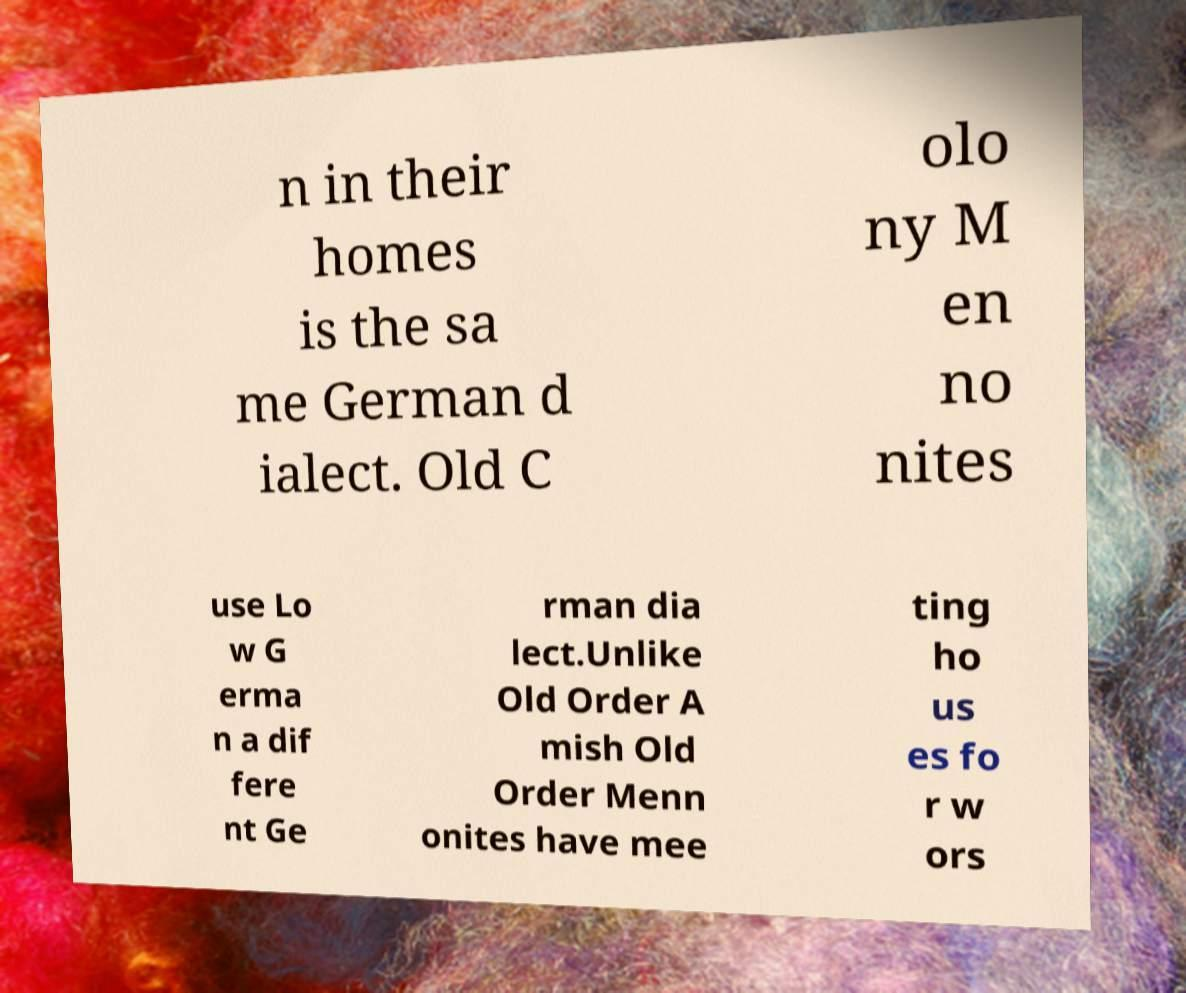For documentation purposes, I need the text within this image transcribed. Could you provide that? n in their homes is the sa me German d ialect. Old C olo ny M en no nites use Lo w G erma n a dif fere nt Ge rman dia lect.Unlike Old Order A mish Old Order Menn onites have mee ting ho us es fo r w ors 